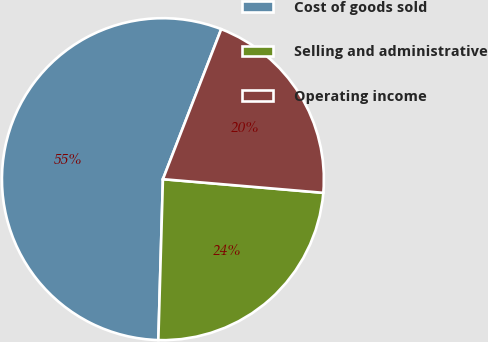<chart> <loc_0><loc_0><loc_500><loc_500><pie_chart><fcel>Cost of goods sold<fcel>Selling and administrative<fcel>Operating income<nl><fcel>55.45%<fcel>24.1%<fcel>20.45%<nl></chart> 